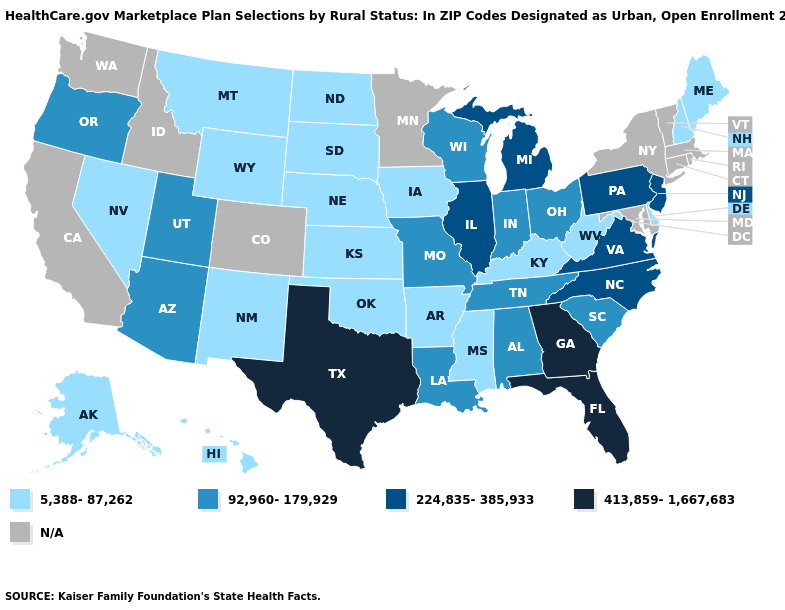Which states hav the highest value in the South?
Concise answer only. Florida, Georgia, Texas. Does Georgia have the highest value in the USA?
Be succinct. Yes. What is the value of West Virginia?
Concise answer only. 5,388-87,262. Name the states that have a value in the range 224,835-385,933?
Write a very short answer. Illinois, Michigan, New Jersey, North Carolina, Pennsylvania, Virginia. Which states have the lowest value in the USA?
Keep it brief. Alaska, Arkansas, Delaware, Hawaii, Iowa, Kansas, Kentucky, Maine, Mississippi, Montana, Nebraska, Nevada, New Hampshire, New Mexico, North Dakota, Oklahoma, South Dakota, West Virginia, Wyoming. Name the states that have a value in the range 413,859-1,667,683?
Keep it brief. Florida, Georgia, Texas. Does the first symbol in the legend represent the smallest category?
Quick response, please. Yes. What is the value of Missouri?
Keep it brief. 92,960-179,929. What is the value of Montana?
Give a very brief answer. 5,388-87,262. What is the lowest value in the South?
Be succinct. 5,388-87,262. What is the value of Utah?
Answer briefly. 92,960-179,929. Does Pennsylvania have the highest value in the Northeast?
Write a very short answer. Yes. What is the lowest value in the MidWest?
Short answer required. 5,388-87,262. Which states have the lowest value in the South?
Answer briefly. Arkansas, Delaware, Kentucky, Mississippi, Oklahoma, West Virginia. 